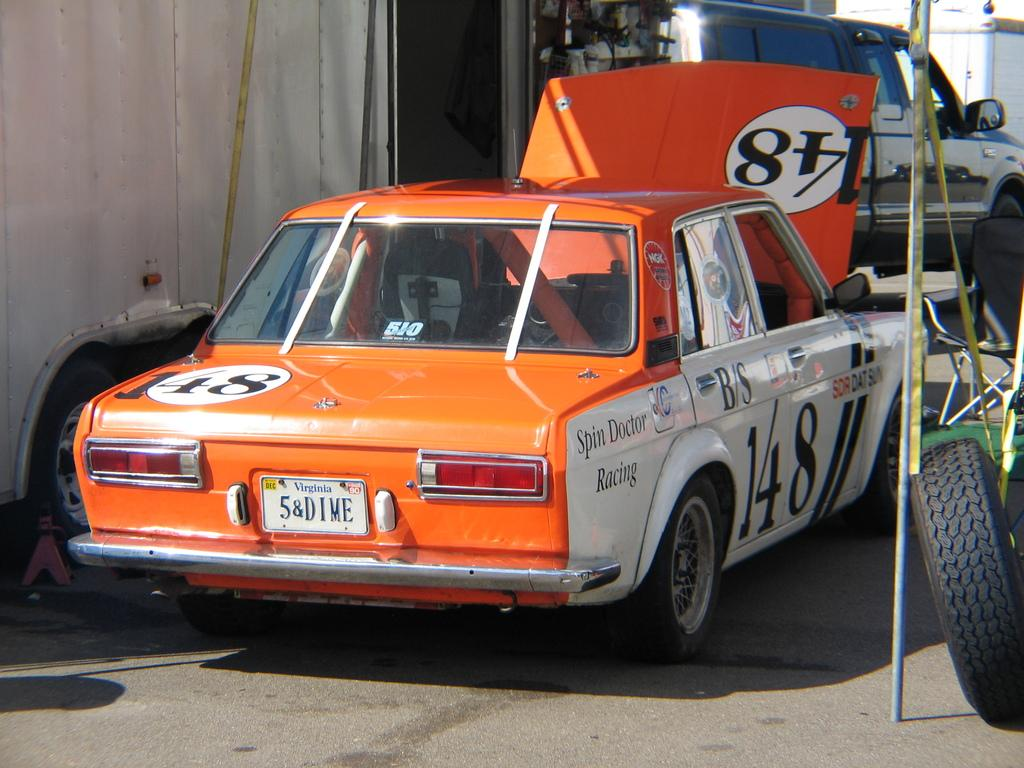How many cars can be seen on the road in the image? There are three cars on the road in the image. What other type of vehicle is visible in the image? There is a truck visible in the background of the image. When was the image taken? The image was taken during the day. What type of bead is being used to rub the truck in the image? There is no bead or rubbing action present in the image; it simply shows three cars on the road and a truck in the background. 